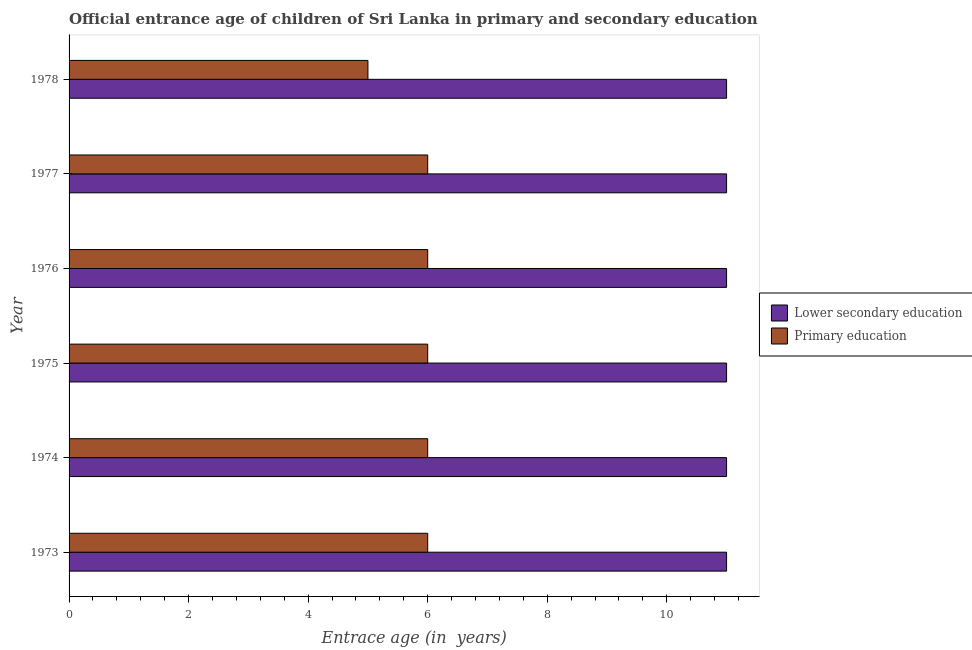How many different coloured bars are there?
Offer a terse response. 2. How many groups of bars are there?
Give a very brief answer. 6. Are the number of bars on each tick of the Y-axis equal?
Ensure brevity in your answer.  Yes. How many bars are there on the 4th tick from the top?
Offer a terse response. 2. How many bars are there on the 5th tick from the bottom?
Offer a very short reply. 2. What is the label of the 4th group of bars from the top?
Your answer should be compact. 1975. In how many cases, is the number of bars for a given year not equal to the number of legend labels?
Give a very brief answer. 0. What is the entrance age of children in lower secondary education in 1977?
Offer a terse response. 11. Across all years, what is the minimum entrance age of children in lower secondary education?
Your answer should be very brief. 11. In which year was the entrance age of chiildren in primary education minimum?
Ensure brevity in your answer.  1978. What is the total entrance age of chiildren in primary education in the graph?
Ensure brevity in your answer.  35. What is the difference between the entrance age of chiildren in primary education in 1975 and that in 1978?
Keep it short and to the point. 1. What is the difference between the entrance age of children in lower secondary education in 1976 and the entrance age of chiildren in primary education in 1978?
Your answer should be compact. 6. In the year 1973, what is the difference between the entrance age of children in lower secondary education and entrance age of chiildren in primary education?
Offer a very short reply. 5. In how many years, is the entrance age of children in lower secondary education greater than 8.4 years?
Provide a succinct answer. 6. What is the ratio of the entrance age of chiildren in primary education in 1976 to that in 1977?
Offer a very short reply. 1. Is the difference between the entrance age of chiildren in primary education in 1973 and 1976 greater than the difference between the entrance age of children in lower secondary education in 1973 and 1976?
Offer a terse response. No. What is the difference between the highest and the second highest entrance age of chiildren in primary education?
Provide a short and direct response. 0. What is the difference between the highest and the lowest entrance age of chiildren in primary education?
Your answer should be very brief. 1. In how many years, is the entrance age of chiildren in primary education greater than the average entrance age of chiildren in primary education taken over all years?
Make the answer very short. 5. What does the 2nd bar from the top in 1977 represents?
Your response must be concise. Lower secondary education. Are all the bars in the graph horizontal?
Your response must be concise. Yes. What is the difference between two consecutive major ticks on the X-axis?
Offer a terse response. 2. Are the values on the major ticks of X-axis written in scientific E-notation?
Provide a succinct answer. No. Does the graph contain any zero values?
Provide a short and direct response. No. Does the graph contain grids?
Your response must be concise. No. Where does the legend appear in the graph?
Offer a terse response. Center right. How are the legend labels stacked?
Your answer should be very brief. Vertical. What is the title of the graph?
Your answer should be very brief. Official entrance age of children of Sri Lanka in primary and secondary education. What is the label or title of the X-axis?
Make the answer very short. Entrace age (in  years). What is the Entrace age (in  years) of Lower secondary education in 1973?
Your response must be concise. 11. What is the Entrace age (in  years) of Primary education in 1975?
Offer a very short reply. 6. What is the Entrace age (in  years) of Primary education in 1976?
Your answer should be compact. 6. What is the Entrace age (in  years) in Lower secondary education in 1977?
Give a very brief answer. 11. Across all years, what is the maximum Entrace age (in  years) of Lower secondary education?
Your response must be concise. 11. Across all years, what is the minimum Entrace age (in  years) in Lower secondary education?
Your answer should be very brief. 11. Across all years, what is the minimum Entrace age (in  years) of Primary education?
Your answer should be compact. 5. What is the total Entrace age (in  years) in Lower secondary education in the graph?
Your answer should be compact. 66. What is the difference between the Entrace age (in  years) of Primary education in 1973 and that in 1975?
Ensure brevity in your answer.  0. What is the difference between the Entrace age (in  years) of Lower secondary education in 1973 and that in 1976?
Provide a short and direct response. 0. What is the difference between the Entrace age (in  years) of Primary education in 1973 and that in 1978?
Offer a very short reply. 1. What is the difference between the Entrace age (in  years) of Lower secondary education in 1974 and that in 1976?
Provide a succinct answer. 0. What is the difference between the Entrace age (in  years) in Primary education in 1974 and that in 1976?
Your answer should be compact. 0. What is the difference between the Entrace age (in  years) of Lower secondary education in 1974 and that in 1977?
Your response must be concise. 0. What is the difference between the Entrace age (in  years) in Lower secondary education in 1974 and that in 1978?
Offer a very short reply. 0. What is the difference between the Entrace age (in  years) in Lower secondary education in 1975 and that in 1977?
Provide a short and direct response. 0. What is the difference between the Entrace age (in  years) of Primary education in 1975 and that in 1977?
Your response must be concise. 0. What is the difference between the Entrace age (in  years) of Lower secondary education in 1975 and that in 1978?
Keep it short and to the point. 0. What is the difference between the Entrace age (in  years) of Primary education in 1975 and that in 1978?
Ensure brevity in your answer.  1. What is the difference between the Entrace age (in  years) in Lower secondary education in 1976 and that in 1977?
Offer a very short reply. 0. What is the difference between the Entrace age (in  years) in Primary education in 1976 and that in 1977?
Make the answer very short. 0. What is the difference between the Entrace age (in  years) of Lower secondary education in 1977 and that in 1978?
Ensure brevity in your answer.  0. What is the difference between the Entrace age (in  years) in Primary education in 1977 and that in 1978?
Offer a terse response. 1. What is the difference between the Entrace age (in  years) of Lower secondary education in 1973 and the Entrace age (in  years) of Primary education in 1974?
Your response must be concise. 5. What is the difference between the Entrace age (in  years) in Lower secondary education in 1973 and the Entrace age (in  years) in Primary education in 1975?
Provide a short and direct response. 5. What is the difference between the Entrace age (in  years) of Lower secondary education in 1973 and the Entrace age (in  years) of Primary education in 1976?
Offer a terse response. 5. What is the difference between the Entrace age (in  years) of Lower secondary education in 1973 and the Entrace age (in  years) of Primary education in 1978?
Make the answer very short. 6. What is the difference between the Entrace age (in  years) of Lower secondary education in 1974 and the Entrace age (in  years) of Primary education in 1975?
Make the answer very short. 5. What is the difference between the Entrace age (in  years) in Lower secondary education in 1974 and the Entrace age (in  years) in Primary education in 1976?
Provide a short and direct response. 5. What is the difference between the Entrace age (in  years) of Lower secondary education in 1974 and the Entrace age (in  years) of Primary education in 1978?
Provide a short and direct response. 6. What is the difference between the Entrace age (in  years) of Lower secondary education in 1975 and the Entrace age (in  years) of Primary education in 1977?
Your answer should be very brief. 5. What is the difference between the Entrace age (in  years) in Lower secondary education in 1975 and the Entrace age (in  years) in Primary education in 1978?
Ensure brevity in your answer.  6. What is the difference between the Entrace age (in  years) in Lower secondary education in 1976 and the Entrace age (in  years) in Primary education in 1977?
Your response must be concise. 5. What is the average Entrace age (in  years) in Lower secondary education per year?
Keep it short and to the point. 11. What is the average Entrace age (in  years) of Primary education per year?
Your answer should be compact. 5.83. What is the ratio of the Entrace age (in  years) of Lower secondary education in 1973 to that in 1974?
Your answer should be compact. 1. What is the ratio of the Entrace age (in  years) of Primary education in 1973 to that in 1974?
Your response must be concise. 1. What is the ratio of the Entrace age (in  years) in Primary education in 1973 to that in 1975?
Provide a short and direct response. 1. What is the ratio of the Entrace age (in  years) in Lower secondary education in 1973 to that in 1976?
Offer a very short reply. 1. What is the ratio of the Entrace age (in  years) of Primary education in 1973 to that in 1976?
Make the answer very short. 1. What is the ratio of the Entrace age (in  years) of Lower secondary education in 1973 to that in 1977?
Your response must be concise. 1. What is the ratio of the Entrace age (in  years) of Primary education in 1973 to that in 1977?
Give a very brief answer. 1. What is the ratio of the Entrace age (in  years) of Primary education in 1974 to that in 1975?
Offer a very short reply. 1. What is the ratio of the Entrace age (in  years) in Lower secondary education in 1974 to that in 1976?
Ensure brevity in your answer.  1. What is the ratio of the Entrace age (in  years) of Lower secondary education in 1974 to that in 1978?
Ensure brevity in your answer.  1. What is the ratio of the Entrace age (in  years) of Lower secondary education in 1975 to that in 1976?
Your response must be concise. 1. What is the ratio of the Entrace age (in  years) of Primary education in 1975 to that in 1977?
Offer a very short reply. 1. What is the ratio of the Entrace age (in  years) of Lower secondary education in 1976 to that in 1977?
Give a very brief answer. 1. What is the ratio of the Entrace age (in  years) in Primary education in 1976 to that in 1977?
Give a very brief answer. 1. What is the ratio of the Entrace age (in  years) in Lower secondary education in 1976 to that in 1978?
Your answer should be compact. 1. What is the ratio of the Entrace age (in  years) of Lower secondary education in 1977 to that in 1978?
Your answer should be very brief. 1. What is the difference between the highest and the second highest Entrace age (in  years) of Lower secondary education?
Your answer should be very brief. 0. What is the difference between the highest and the second highest Entrace age (in  years) in Primary education?
Offer a very short reply. 0. What is the difference between the highest and the lowest Entrace age (in  years) in Primary education?
Your answer should be compact. 1. 